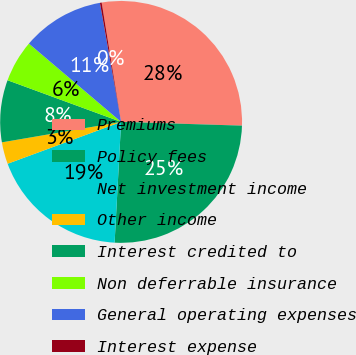Convert chart to OTSL. <chart><loc_0><loc_0><loc_500><loc_500><pie_chart><fcel>Premiums<fcel>Policy fees<fcel>Net investment income<fcel>Other income<fcel>Interest credited to<fcel>Non deferrable insurance<fcel>General operating expenses<fcel>Interest expense<nl><fcel>28.06%<fcel>25.36%<fcel>18.52%<fcel>2.92%<fcel>8.3%<fcel>5.61%<fcel>10.99%<fcel>0.23%<nl></chart> 